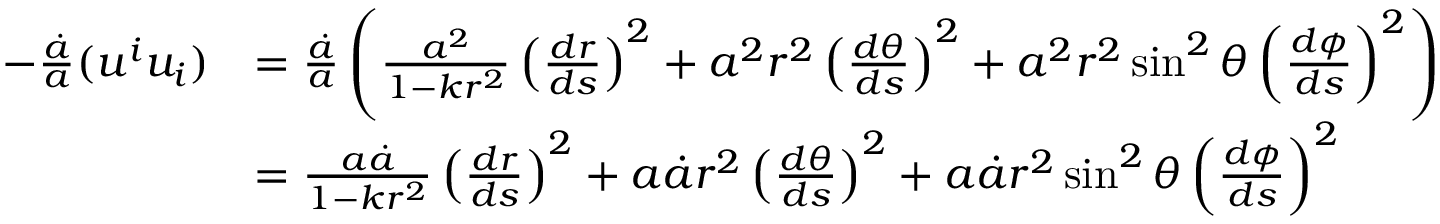<formula> <loc_0><loc_0><loc_500><loc_500>\begin{array} { r l } { - \frac { \dot { a } } { a } ( u ^ { i } u _ { i } ) } & { = \frac { \dot { a } } { a } \left ( \frac { a ^ { 2 } } { 1 - k r ^ { 2 } } \left ( \frac { d r } { d s } \right ) ^ { 2 } + a ^ { 2 } r ^ { 2 } \left ( \frac { d \theta } { d s } \right ) ^ { 2 } + a ^ { 2 } r ^ { 2 } \sin ^ { 2 } \theta \left ( \frac { d \phi } { d s } \right ) ^ { 2 } \right ) } \\ & { = \frac { a \dot { a } } { 1 - k r ^ { 2 } } \left ( \frac { d r } { d s } \right ) ^ { 2 } + a \dot { a } r ^ { 2 } \left ( \frac { d \theta } { d s } \right ) ^ { 2 } + a \dot { a } r ^ { 2 } \sin ^ { 2 } \theta \left ( \frac { d \phi } { d s } \right ) ^ { 2 } } \end{array}</formula> 